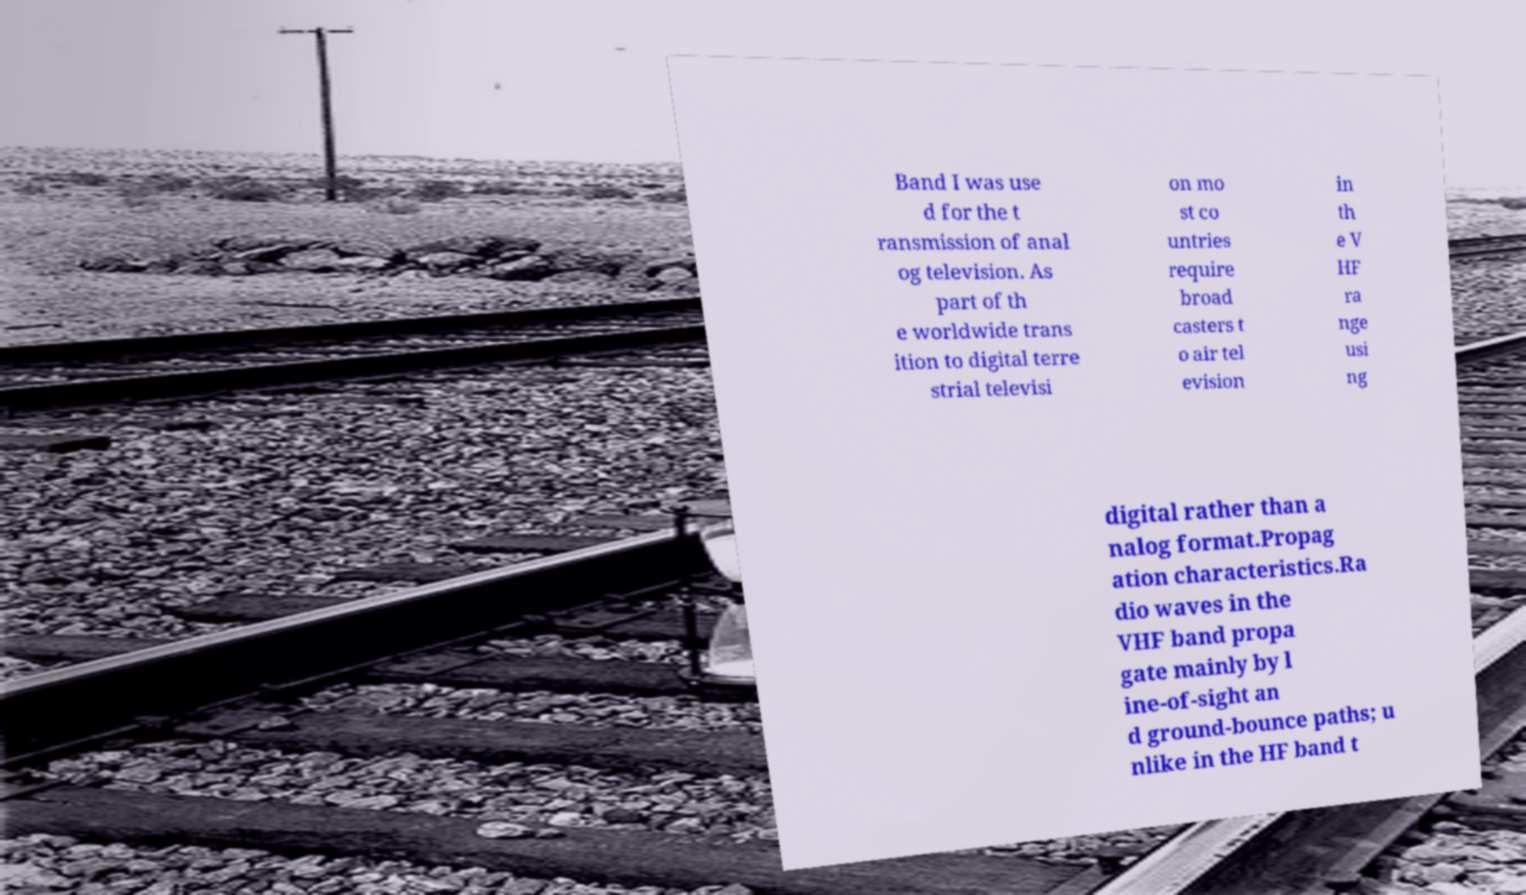Please read and relay the text visible in this image. What does it say? Band I was use d for the t ransmission of anal og television. As part of th e worldwide trans ition to digital terre strial televisi on mo st co untries require broad casters t o air tel evision in th e V HF ra nge usi ng digital rather than a nalog format.Propag ation characteristics.Ra dio waves in the VHF band propa gate mainly by l ine-of-sight an d ground-bounce paths; u nlike in the HF band t 